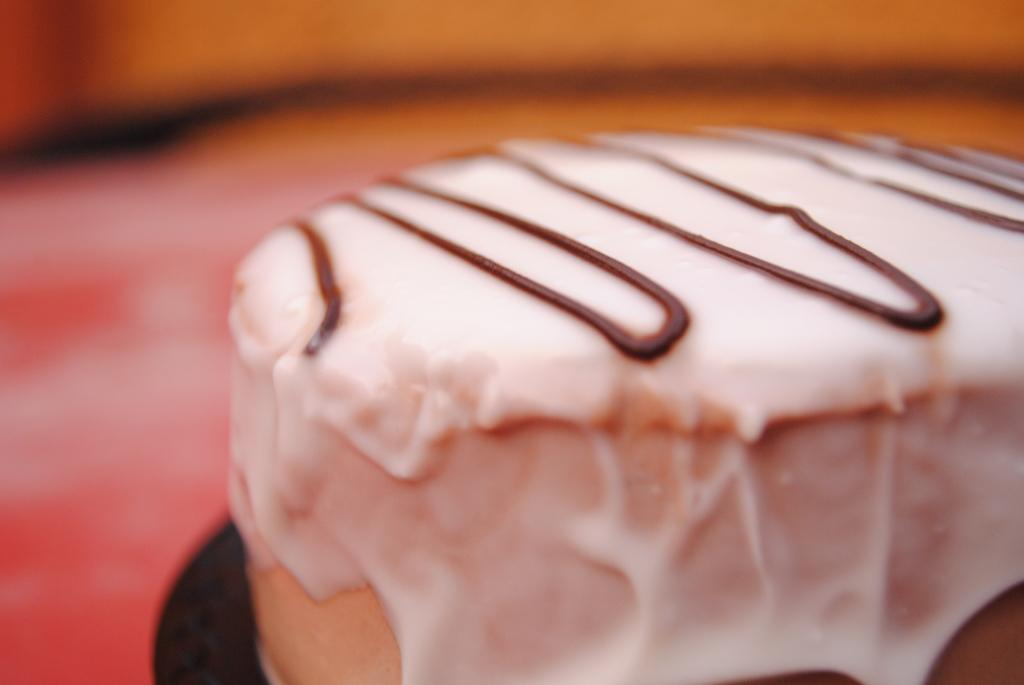What type of dessert is visible in the image? There is a piece of cake with cream in the image. Can you describe the background of the image? The background of the image appears blurry. How many snails can be seen crawling on the neck of the person in the image? There is no person or snails present in the image; it features a piece of cake with cream and a blurry background. 